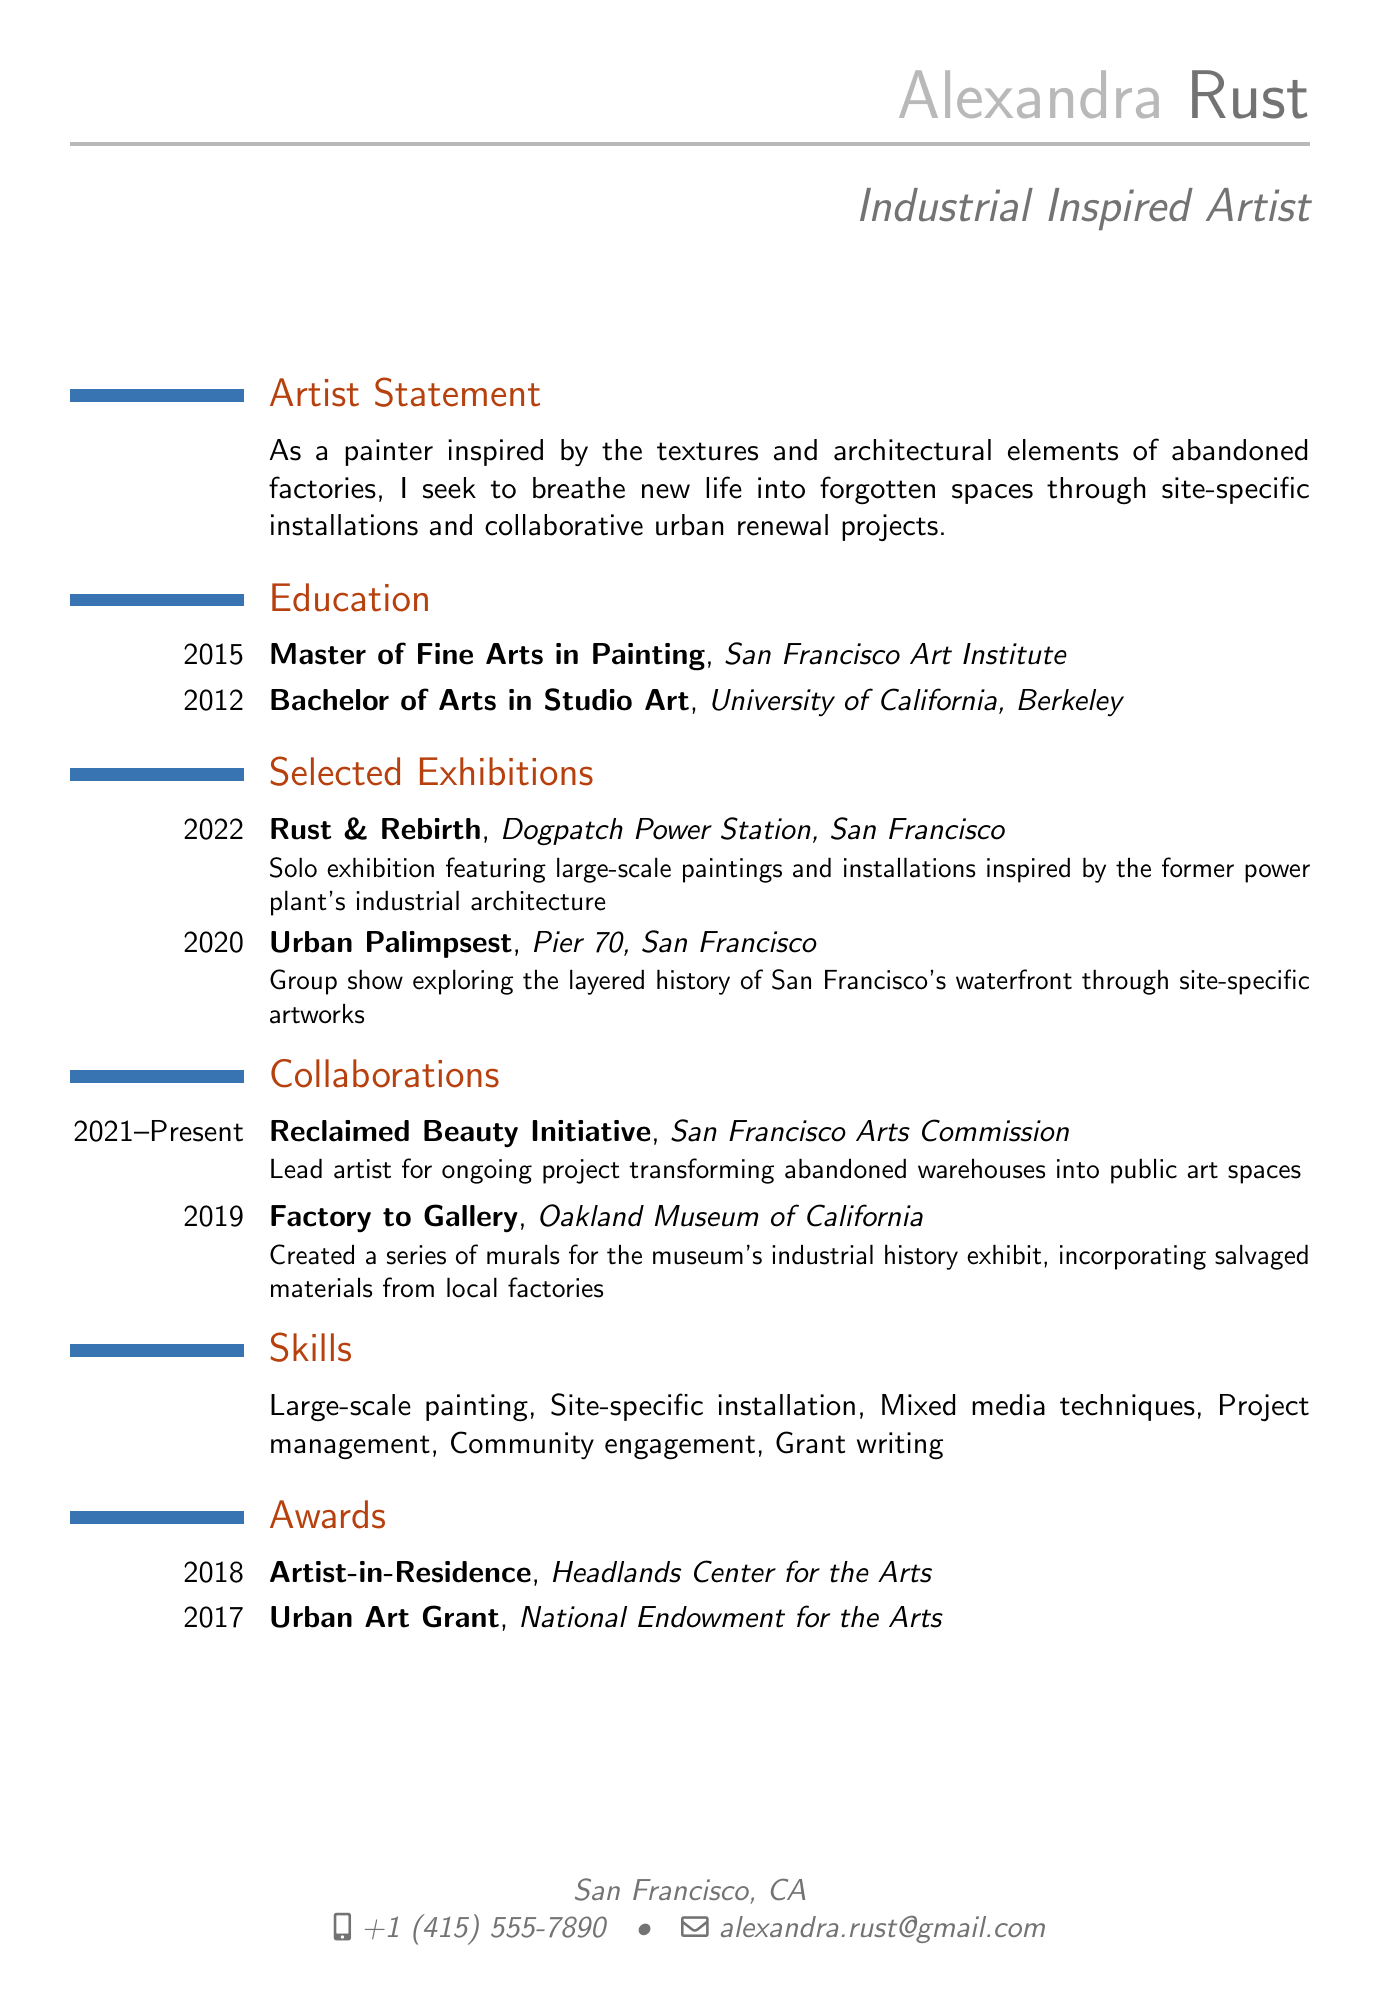what is Alexandra Rust's email address? The email address is listed in the personal information section of the document.
Answer: alexandra.rust@gmail.com what project is Alexandra Rust currently working on? The current project mentioned is detailed under collaborations and refers to an ongoing project transforming abandoned warehouses into public art spaces.
Answer: Reclaimed Beauty Initiative in what year did Alexandra Rust complete her Master of Fine Arts in Painting? The year of completion is stated under the education section of the document.
Answer: 2015 which exhibition featured a rail yard-inspired theme? This is inferred by examining the exhibitions. The title suggests an exploration of urban textures, which is present in the solo theme of the exhibition.
Answer: Rust & Rebirth what award did Alexandra Rust receive in 2018? The award is noted in the awards section of the document.
Answer: Artist-in-Residence how many years has Alexandra Rust been involved in the Reclaimed Beauty Initiative? The duration is calculated from the start year to the present based on the project details.
Answer: 2 years what type of techniques is Alexandra Rust skilled in according to the resume? The skills section lists specific techniques that Alexandra is proficient in.
Answer: Mixed media techniques which organization awarded Alexandra the Urban Art Grant in 2017? This information is mentioned in the awards section of the document.
Answer: National Endowment for the Arts 